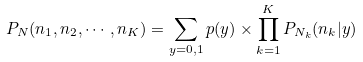<formula> <loc_0><loc_0><loc_500><loc_500>P _ { N } ( n _ { 1 } , n _ { 2 } , \cdots , n _ { K } ) = \sum _ { y = 0 , 1 } p ( y ) \times \prod _ { k = 1 } ^ { K } P _ { N _ { k } } ( n _ { k } | y )</formula> 